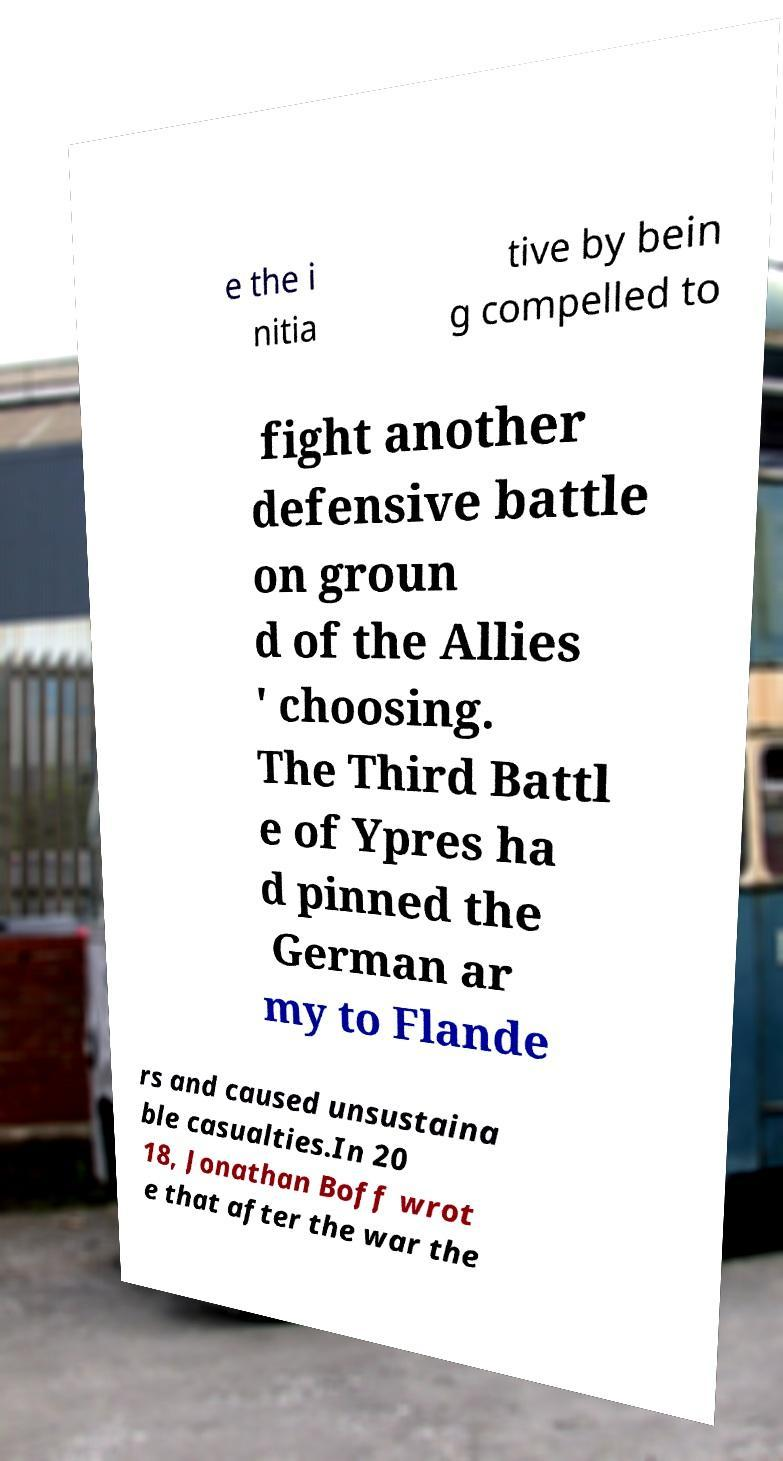There's text embedded in this image that I need extracted. Can you transcribe it verbatim? e the i nitia tive by bein g compelled to fight another defensive battle on groun d of the Allies ' choosing. The Third Battl e of Ypres ha d pinned the German ar my to Flande rs and caused unsustaina ble casualties.In 20 18, Jonathan Boff wrot e that after the war the 